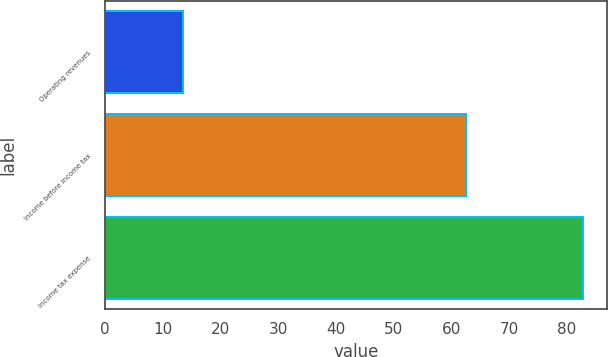<chart> <loc_0><loc_0><loc_500><loc_500><bar_chart><fcel>Operating revenues<fcel>Income before income tax<fcel>Income tax expense<nl><fcel>13.5<fcel>62.5<fcel>82.9<nl></chart> 